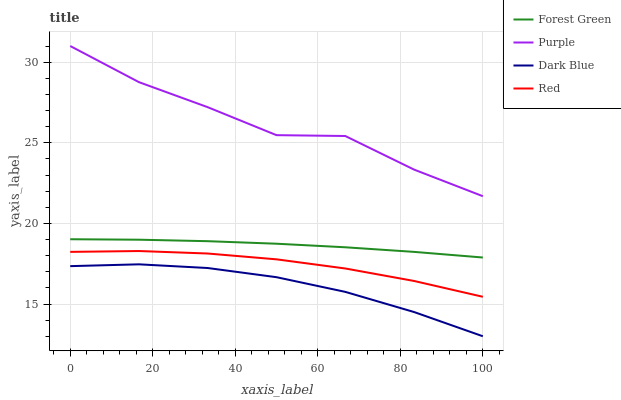Does Dark Blue have the minimum area under the curve?
Answer yes or no. Yes. Does Purple have the maximum area under the curve?
Answer yes or no. Yes. Does Forest Green have the minimum area under the curve?
Answer yes or no. No. Does Forest Green have the maximum area under the curve?
Answer yes or no. No. Is Forest Green the smoothest?
Answer yes or no. Yes. Is Purple the roughest?
Answer yes or no. Yes. Is Dark Blue the smoothest?
Answer yes or no. No. Is Dark Blue the roughest?
Answer yes or no. No. Does Forest Green have the lowest value?
Answer yes or no. No. Does Purple have the highest value?
Answer yes or no. Yes. Does Forest Green have the highest value?
Answer yes or no. No. Is Forest Green less than Purple?
Answer yes or no. Yes. Is Forest Green greater than Dark Blue?
Answer yes or no. Yes. Does Forest Green intersect Purple?
Answer yes or no. No. 